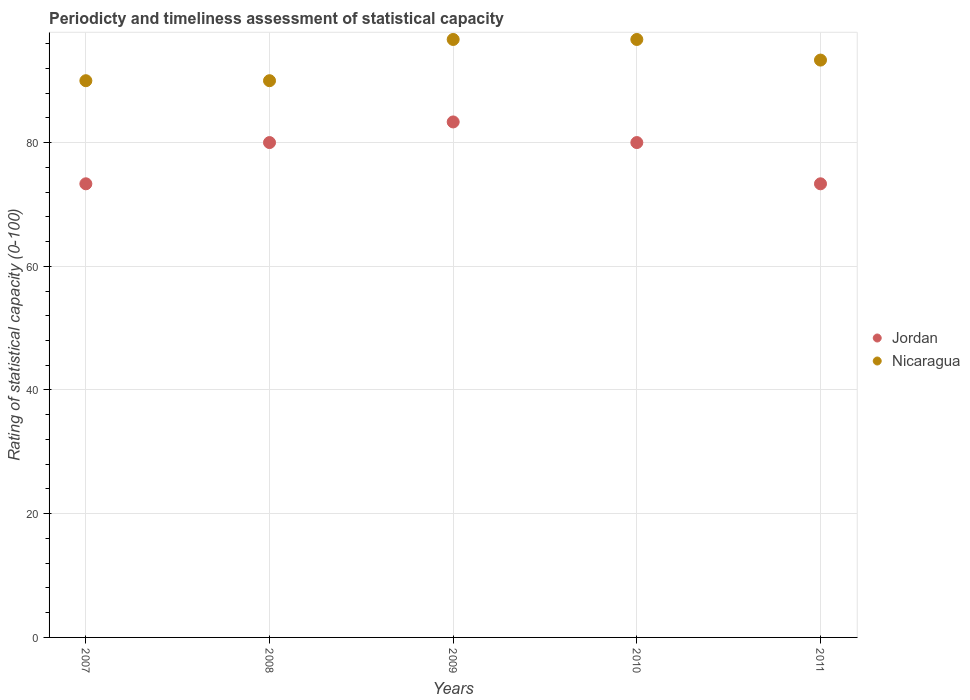How many different coloured dotlines are there?
Ensure brevity in your answer.  2. Is the number of dotlines equal to the number of legend labels?
Keep it short and to the point. Yes. Across all years, what is the maximum rating of statistical capacity in Nicaragua?
Provide a succinct answer. 96.67. Across all years, what is the minimum rating of statistical capacity in Nicaragua?
Your response must be concise. 90. In which year was the rating of statistical capacity in Nicaragua maximum?
Ensure brevity in your answer.  2009. In which year was the rating of statistical capacity in Jordan minimum?
Your response must be concise. 2007. What is the total rating of statistical capacity in Nicaragua in the graph?
Provide a succinct answer. 466.67. What is the difference between the rating of statistical capacity in Nicaragua in 2009 and that in 2011?
Your answer should be very brief. 3.33. What is the difference between the rating of statistical capacity in Nicaragua in 2008 and the rating of statistical capacity in Jordan in 2009?
Provide a succinct answer. 6.67. What is the average rating of statistical capacity in Nicaragua per year?
Your answer should be compact. 93.33. In the year 2011, what is the difference between the rating of statistical capacity in Jordan and rating of statistical capacity in Nicaragua?
Your response must be concise. -20. In how many years, is the rating of statistical capacity in Nicaragua greater than 80?
Your answer should be very brief. 5. Is the rating of statistical capacity in Jordan in 2009 less than that in 2011?
Provide a short and direct response. No. What is the difference between the highest and the second highest rating of statistical capacity in Jordan?
Offer a terse response. 3.33. What is the difference between the highest and the lowest rating of statistical capacity in Nicaragua?
Make the answer very short. 6.67. Does the rating of statistical capacity in Jordan monotonically increase over the years?
Provide a succinct answer. No. Is the rating of statistical capacity in Nicaragua strictly greater than the rating of statistical capacity in Jordan over the years?
Your answer should be compact. Yes. Is the rating of statistical capacity in Nicaragua strictly less than the rating of statistical capacity in Jordan over the years?
Keep it short and to the point. No. How many dotlines are there?
Your answer should be very brief. 2. How many years are there in the graph?
Give a very brief answer. 5. Does the graph contain any zero values?
Give a very brief answer. No. Does the graph contain grids?
Your answer should be compact. Yes. Where does the legend appear in the graph?
Ensure brevity in your answer.  Center right. How many legend labels are there?
Provide a succinct answer. 2. How are the legend labels stacked?
Your response must be concise. Vertical. What is the title of the graph?
Your answer should be compact. Periodicty and timeliness assessment of statistical capacity. What is the label or title of the X-axis?
Offer a terse response. Years. What is the label or title of the Y-axis?
Your answer should be very brief. Rating of statistical capacity (0-100). What is the Rating of statistical capacity (0-100) in Jordan in 2007?
Offer a very short reply. 73.33. What is the Rating of statistical capacity (0-100) of Nicaragua in 2007?
Keep it short and to the point. 90. What is the Rating of statistical capacity (0-100) of Jordan in 2008?
Offer a very short reply. 80. What is the Rating of statistical capacity (0-100) of Jordan in 2009?
Make the answer very short. 83.33. What is the Rating of statistical capacity (0-100) of Nicaragua in 2009?
Ensure brevity in your answer.  96.67. What is the Rating of statistical capacity (0-100) in Nicaragua in 2010?
Keep it short and to the point. 96.67. What is the Rating of statistical capacity (0-100) in Jordan in 2011?
Provide a succinct answer. 73.33. What is the Rating of statistical capacity (0-100) of Nicaragua in 2011?
Provide a short and direct response. 93.33. Across all years, what is the maximum Rating of statistical capacity (0-100) of Jordan?
Your answer should be compact. 83.33. Across all years, what is the maximum Rating of statistical capacity (0-100) of Nicaragua?
Ensure brevity in your answer.  96.67. Across all years, what is the minimum Rating of statistical capacity (0-100) of Jordan?
Give a very brief answer. 73.33. Across all years, what is the minimum Rating of statistical capacity (0-100) of Nicaragua?
Give a very brief answer. 90. What is the total Rating of statistical capacity (0-100) in Jordan in the graph?
Your response must be concise. 390. What is the total Rating of statistical capacity (0-100) in Nicaragua in the graph?
Your answer should be very brief. 466.67. What is the difference between the Rating of statistical capacity (0-100) in Jordan in 2007 and that in 2008?
Your answer should be very brief. -6.67. What is the difference between the Rating of statistical capacity (0-100) in Nicaragua in 2007 and that in 2009?
Give a very brief answer. -6.67. What is the difference between the Rating of statistical capacity (0-100) in Jordan in 2007 and that in 2010?
Your answer should be compact. -6.67. What is the difference between the Rating of statistical capacity (0-100) in Nicaragua in 2007 and that in 2010?
Offer a terse response. -6.67. What is the difference between the Rating of statistical capacity (0-100) of Jordan in 2007 and that in 2011?
Your response must be concise. 0. What is the difference between the Rating of statistical capacity (0-100) of Nicaragua in 2007 and that in 2011?
Keep it short and to the point. -3.33. What is the difference between the Rating of statistical capacity (0-100) of Jordan in 2008 and that in 2009?
Make the answer very short. -3.33. What is the difference between the Rating of statistical capacity (0-100) in Nicaragua in 2008 and that in 2009?
Keep it short and to the point. -6.67. What is the difference between the Rating of statistical capacity (0-100) in Nicaragua in 2008 and that in 2010?
Provide a succinct answer. -6.67. What is the difference between the Rating of statistical capacity (0-100) of Jordan in 2008 and that in 2011?
Make the answer very short. 6.67. What is the difference between the Rating of statistical capacity (0-100) of Jordan in 2007 and the Rating of statistical capacity (0-100) of Nicaragua in 2008?
Your answer should be compact. -16.67. What is the difference between the Rating of statistical capacity (0-100) in Jordan in 2007 and the Rating of statistical capacity (0-100) in Nicaragua in 2009?
Provide a short and direct response. -23.33. What is the difference between the Rating of statistical capacity (0-100) in Jordan in 2007 and the Rating of statistical capacity (0-100) in Nicaragua in 2010?
Your answer should be compact. -23.33. What is the difference between the Rating of statistical capacity (0-100) in Jordan in 2007 and the Rating of statistical capacity (0-100) in Nicaragua in 2011?
Make the answer very short. -20. What is the difference between the Rating of statistical capacity (0-100) in Jordan in 2008 and the Rating of statistical capacity (0-100) in Nicaragua in 2009?
Offer a terse response. -16.67. What is the difference between the Rating of statistical capacity (0-100) in Jordan in 2008 and the Rating of statistical capacity (0-100) in Nicaragua in 2010?
Make the answer very short. -16.67. What is the difference between the Rating of statistical capacity (0-100) in Jordan in 2008 and the Rating of statistical capacity (0-100) in Nicaragua in 2011?
Give a very brief answer. -13.33. What is the difference between the Rating of statistical capacity (0-100) in Jordan in 2009 and the Rating of statistical capacity (0-100) in Nicaragua in 2010?
Provide a short and direct response. -13.33. What is the difference between the Rating of statistical capacity (0-100) of Jordan in 2009 and the Rating of statistical capacity (0-100) of Nicaragua in 2011?
Your answer should be very brief. -10. What is the difference between the Rating of statistical capacity (0-100) in Jordan in 2010 and the Rating of statistical capacity (0-100) in Nicaragua in 2011?
Offer a very short reply. -13.33. What is the average Rating of statistical capacity (0-100) of Jordan per year?
Make the answer very short. 78. What is the average Rating of statistical capacity (0-100) of Nicaragua per year?
Make the answer very short. 93.33. In the year 2007, what is the difference between the Rating of statistical capacity (0-100) of Jordan and Rating of statistical capacity (0-100) of Nicaragua?
Make the answer very short. -16.67. In the year 2009, what is the difference between the Rating of statistical capacity (0-100) in Jordan and Rating of statistical capacity (0-100) in Nicaragua?
Provide a succinct answer. -13.33. In the year 2010, what is the difference between the Rating of statistical capacity (0-100) in Jordan and Rating of statistical capacity (0-100) in Nicaragua?
Ensure brevity in your answer.  -16.67. What is the ratio of the Rating of statistical capacity (0-100) in Jordan in 2007 to that in 2008?
Keep it short and to the point. 0.92. What is the ratio of the Rating of statistical capacity (0-100) in Nicaragua in 2007 to that in 2008?
Provide a short and direct response. 1. What is the ratio of the Rating of statistical capacity (0-100) in Jordan in 2007 to that in 2009?
Provide a succinct answer. 0.88. What is the ratio of the Rating of statistical capacity (0-100) of Nicaragua in 2007 to that in 2009?
Keep it short and to the point. 0.93. What is the ratio of the Rating of statistical capacity (0-100) in Nicaragua in 2007 to that in 2010?
Make the answer very short. 0.93. What is the ratio of the Rating of statistical capacity (0-100) of Jordan in 2007 to that in 2011?
Ensure brevity in your answer.  1. What is the ratio of the Rating of statistical capacity (0-100) in Nicaragua in 2007 to that in 2011?
Your answer should be compact. 0.96. What is the ratio of the Rating of statistical capacity (0-100) of Jordan in 2008 to that in 2009?
Offer a very short reply. 0.96. What is the ratio of the Rating of statistical capacity (0-100) in Nicaragua in 2008 to that in 2009?
Offer a terse response. 0.93. What is the ratio of the Rating of statistical capacity (0-100) of Nicaragua in 2008 to that in 2010?
Ensure brevity in your answer.  0.93. What is the ratio of the Rating of statistical capacity (0-100) in Jordan in 2009 to that in 2010?
Keep it short and to the point. 1.04. What is the ratio of the Rating of statistical capacity (0-100) in Jordan in 2009 to that in 2011?
Offer a terse response. 1.14. What is the ratio of the Rating of statistical capacity (0-100) of Nicaragua in 2009 to that in 2011?
Provide a short and direct response. 1.04. What is the ratio of the Rating of statistical capacity (0-100) in Jordan in 2010 to that in 2011?
Provide a succinct answer. 1.09. What is the ratio of the Rating of statistical capacity (0-100) in Nicaragua in 2010 to that in 2011?
Provide a short and direct response. 1.04. What is the difference between the highest and the second highest Rating of statistical capacity (0-100) of Jordan?
Make the answer very short. 3.33. What is the difference between the highest and the second highest Rating of statistical capacity (0-100) in Nicaragua?
Keep it short and to the point. 0. What is the difference between the highest and the lowest Rating of statistical capacity (0-100) of Jordan?
Ensure brevity in your answer.  10. What is the difference between the highest and the lowest Rating of statistical capacity (0-100) in Nicaragua?
Your answer should be very brief. 6.67. 